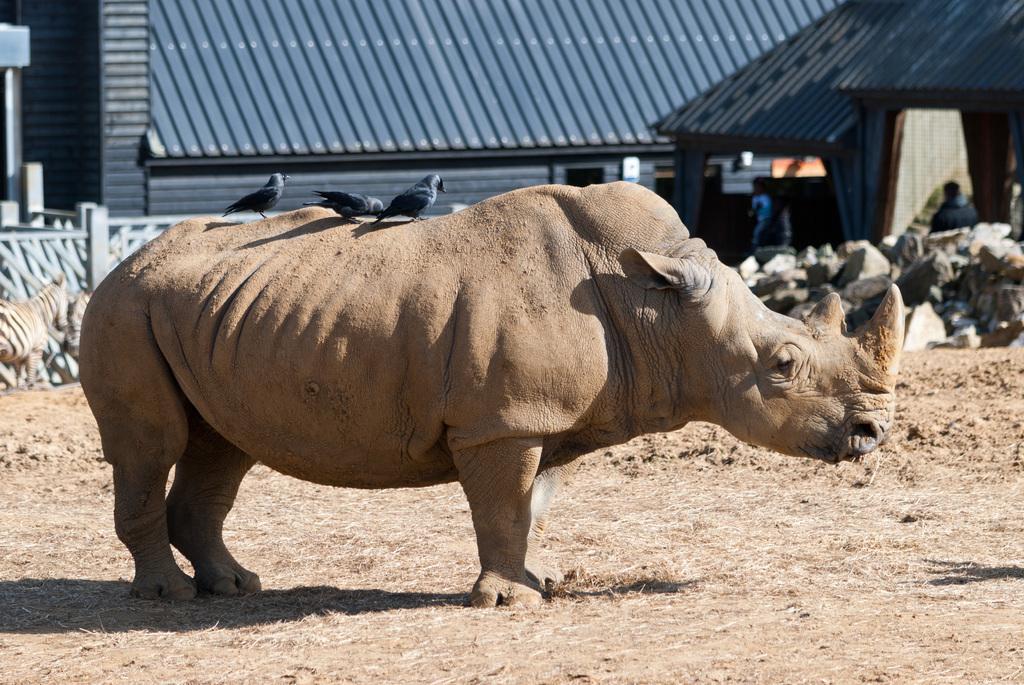In one or two sentences, can you explain what this image depicts? In this image, we can see an animal standing on the grass, we can see some crows on the animal. In the background, we can see some rocks, we can see the shed. 